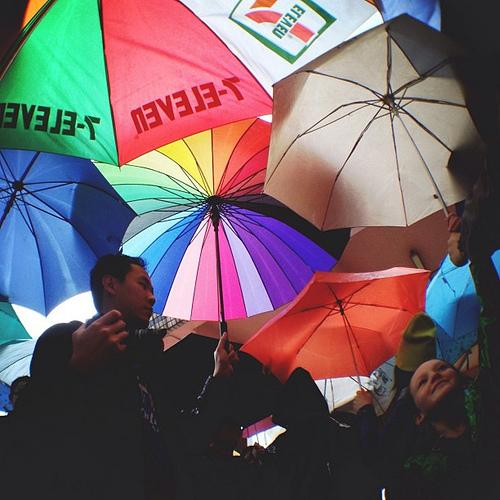Describe any identifiable landmarks, labels, or signs in the image. The 7eleven logo appears on a multicolored umbrella among the crowd. What color is the hat of the child among the crowd? The child's hat color among the crowd is yellow. Which type of umbrella has the 7eleven logo on it? A multicolored umbrella has the 7eleven logo on it. Is there any writing or logo present on the umbrellas? If so, describe it. There is the 7eleven logo written on the multicolored umbrella, with the word "7eleven" spelled backwards on the red and green parts. Identify the primary object in the image and its color. A vibrant multicolored umbrella is the main object in the image. How many different umbrellas can be seen and what is unique about each one? Five umbrellas are visible: a multicolored umbrella with the 7eleven logo, a bright blue umbrella, a small orange umbrella, a beige umbrella with a silver handle, and a large rainbow design umbrella. What is the overarching sentiment of the image? The image showcases an upbeat and colorful atmosphere due to the various vivid umbrellas and people's interactions. Provide a brief description of the scene with the group of people together. There is a group of people holding various colorful umbrellas, with some interacting with each other, a child wearing a yellow hat and a person wearing a hoodie. Which two umbrellas appear to be the largest? The multicolored 7eleven umbrella and a vibrant multicolored umbrella appear to be the largest. What is the roof visible through the umbrellas? a bright splash of sky Is there a man standing under the umbrellas in the image? Yes Select one of the following colors for a child's hat in the image.  Answer:  Identify the type of jacket worn by a child in the image. green Which logo is written backward on two parts of a multicolored umbrella? 7eleven What kind of event involves a crowd holding a group of umbrellas? an outdoor gathering Describe the activity of a person wearing a hood. Holding an umbrella How is the concept of the 7eleven logo shown in the image? On a multicolored umbrella Describe the scene where a man is holding a colorful umbrella. He's standing among a crowd of people with various other umbrellas. Identify the type of hat being worn by the person carrying a red umbrella. goofy hat Describe the umbrella with the 7eleven logo. multicolored with 7eleven logo What is the description of a large blue umbrella in the image? It's among many other colorful umbrellas Give a summary of the image that involves many open umbrellas. A crowd of people holding various colorful umbrellas at an outdoor gathering. What is the color of the umbrella with a silver handle? beige 